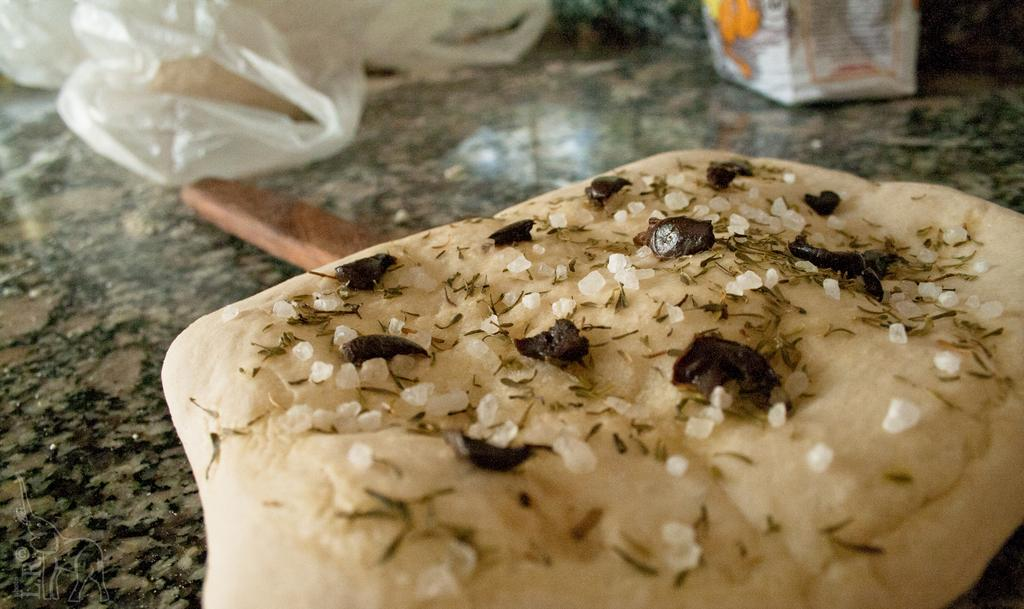What type of food item is visible in the image? There is a food item in the image, but the specific type cannot be determined from the provided facts. What object is present alongside the food item? There is a wooden stick in the image. What might be used to cover the food item? There are covers in the image. What type of container is present in the image? There is a box in the image. What type of surface is visible in the image? The granite surface is present in the image. How many beetles can be seen crawling on the granite surface in the image? There are no beetles present in the image; only a food item, wooden stick, covers, box, and granite surface are visible. What type of doctor is attending to the ducks in the image? There are no ducks or doctors present in the image. 